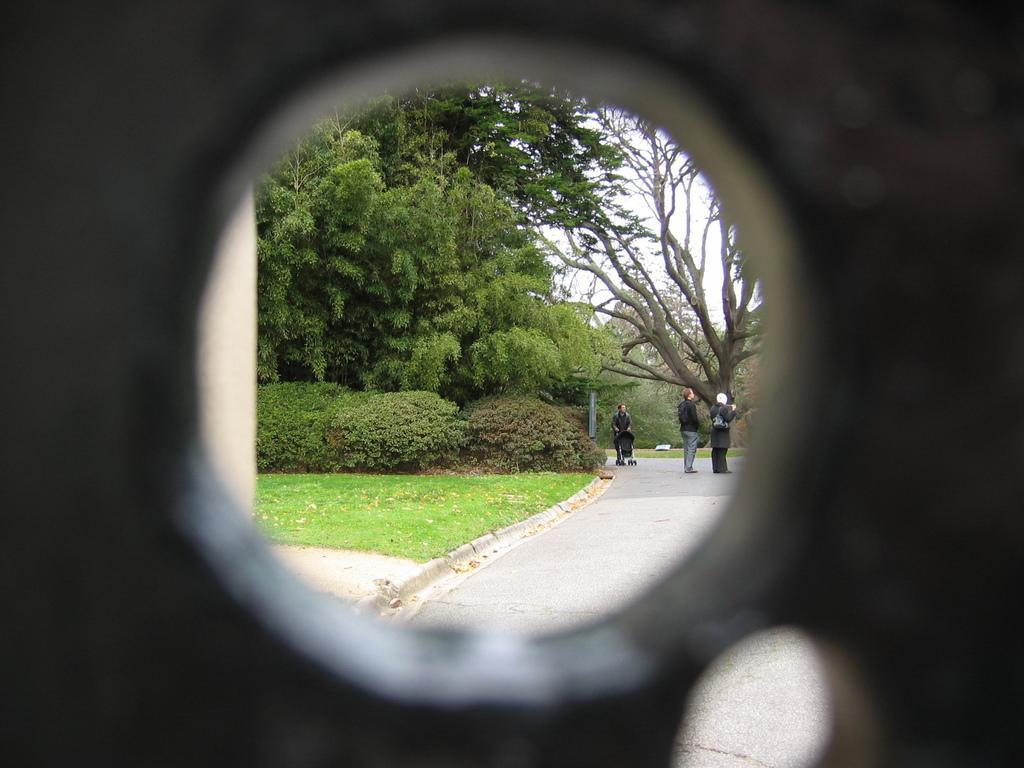Please provide a concise description of this image. This picture contains a hole from which we can see people standing on the road. Beside them, we see the grass and there are many trees in the background. This picture is clicked from the room. 